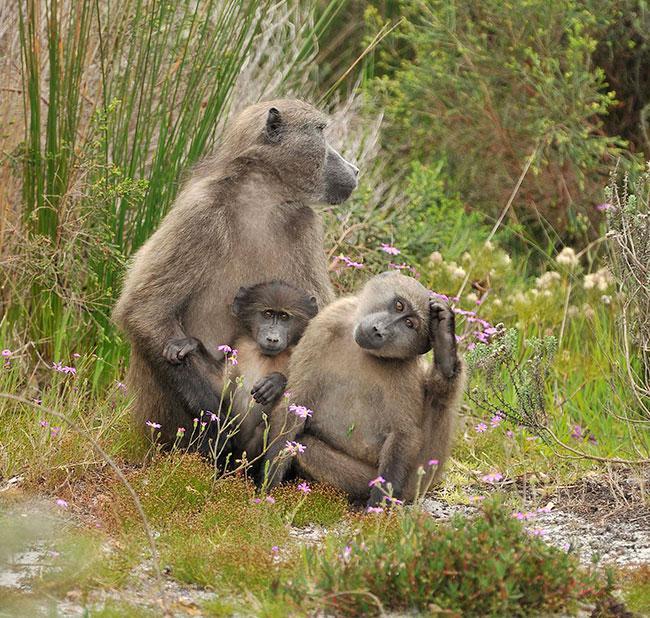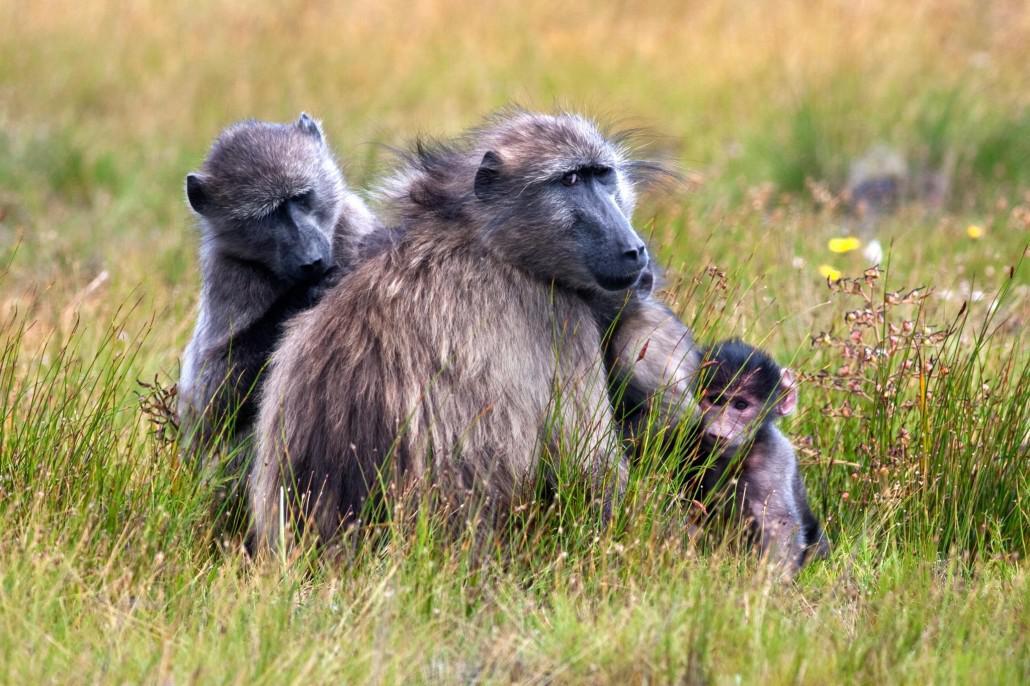The first image is the image on the left, the second image is the image on the right. Given the left and right images, does the statement "At least two animals are huddled together." hold true? Answer yes or no. Yes. The first image is the image on the left, the second image is the image on the right. For the images displayed, is the sentence "Some chimpanzees are walking." factually correct? Answer yes or no. No. 